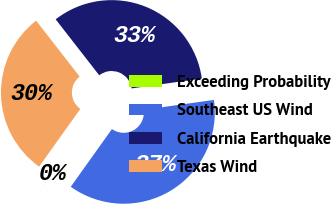Convert chart. <chart><loc_0><loc_0><loc_500><loc_500><pie_chart><fcel>Exceeding Probability<fcel>Southeast US Wind<fcel>California Earthquake<fcel>Texas Wind<nl><fcel>0.01%<fcel>37.09%<fcel>33.3%<fcel>29.59%<nl></chart> 